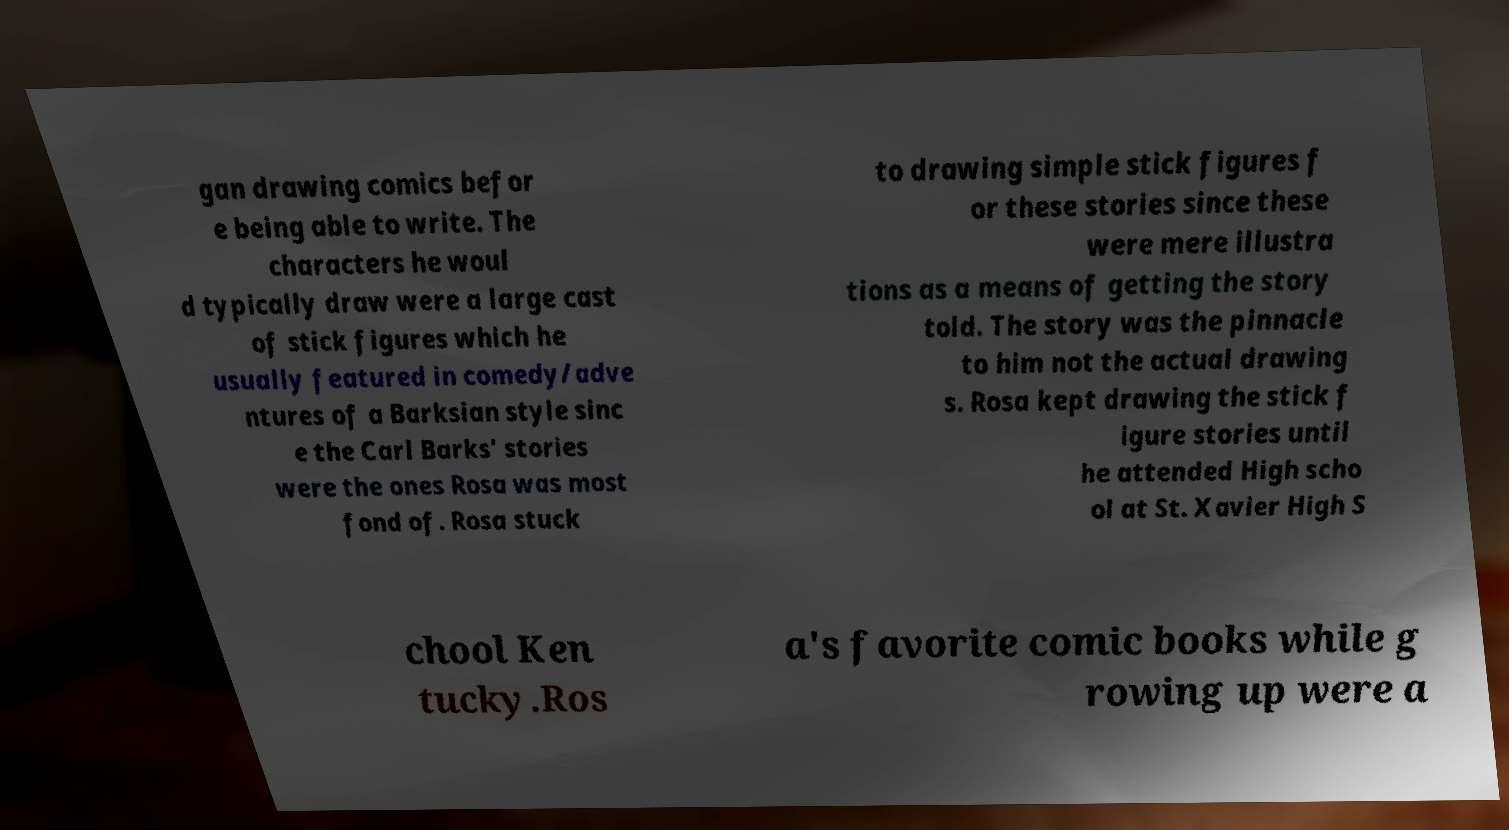There's text embedded in this image that I need extracted. Can you transcribe it verbatim? gan drawing comics befor e being able to write. The characters he woul d typically draw were a large cast of stick figures which he usually featured in comedy/adve ntures of a Barksian style sinc e the Carl Barks' stories were the ones Rosa was most fond of. Rosa stuck to drawing simple stick figures f or these stories since these were mere illustra tions as a means of getting the story told. The story was the pinnacle to him not the actual drawing s. Rosa kept drawing the stick f igure stories until he attended High scho ol at St. Xavier High S chool Ken tucky.Ros a's favorite comic books while g rowing up were a 